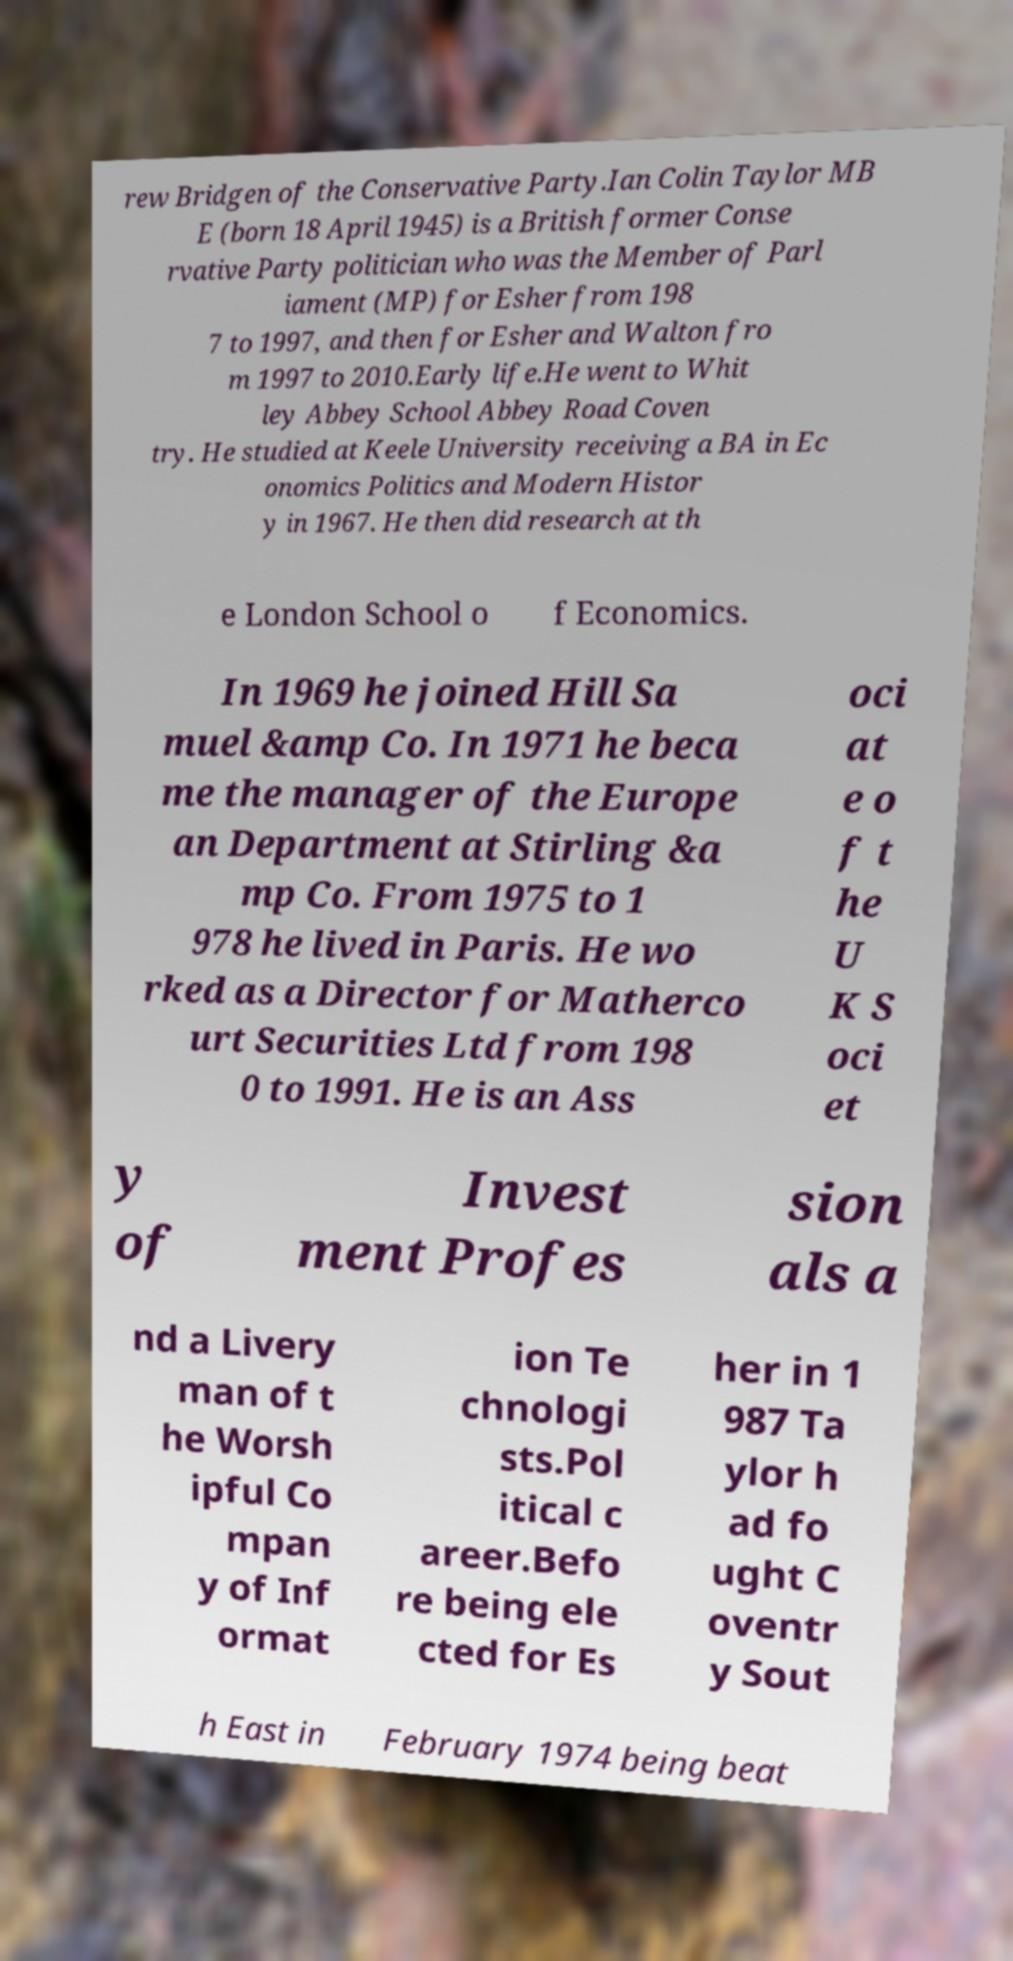For documentation purposes, I need the text within this image transcribed. Could you provide that? rew Bridgen of the Conservative Party.Ian Colin Taylor MB E (born 18 April 1945) is a British former Conse rvative Party politician who was the Member of Parl iament (MP) for Esher from 198 7 to 1997, and then for Esher and Walton fro m 1997 to 2010.Early life.He went to Whit ley Abbey School Abbey Road Coven try. He studied at Keele University receiving a BA in Ec onomics Politics and Modern Histor y in 1967. He then did research at th e London School o f Economics. In 1969 he joined Hill Sa muel &amp Co. In 1971 he beca me the manager of the Europe an Department at Stirling &a mp Co. From 1975 to 1 978 he lived in Paris. He wo rked as a Director for Matherco urt Securities Ltd from 198 0 to 1991. He is an Ass oci at e o f t he U K S oci et y of Invest ment Profes sion als a nd a Livery man of t he Worsh ipful Co mpan y of Inf ormat ion Te chnologi sts.Pol itical c areer.Befo re being ele cted for Es her in 1 987 Ta ylor h ad fo ught C oventr y Sout h East in February 1974 being beat 